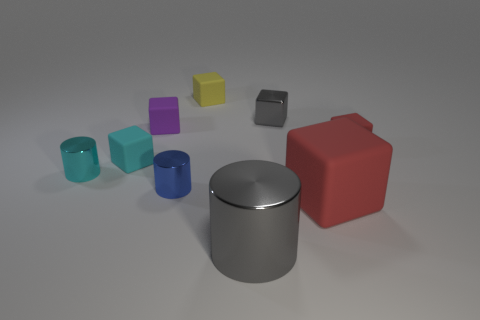Does the cube behind the metallic block have the same size as the small blue metal thing?
Give a very brief answer. Yes. What number of small metallic things are on the left side of the tiny cyan block?
Ensure brevity in your answer.  1. Are there any brown matte blocks of the same size as the blue metal object?
Your answer should be compact. No. Does the small metal cube have the same color as the big metal thing?
Your answer should be compact. Yes. There is a large thing that is to the right of the large metallic object in front of the tiny purple thing; what color is it?
Your answer should be compact. Red. How many objects are behind the small cyan block and to the right of the tiny gray object?
Your response must be concise. 1. How many other big gray metal objects are the same shape as the big metallic thing?
Your response must be concise. 0. Do the small yellow thing and the small cyan block have the same material?
Your answer should be very brief. Yes. There is a gray metallic thing that is in front of the gray object to the right of the gray cylinder; what shape is it?
Your response must be concise. Cylinder. There is a red rubber thing that is in front of the tiny blue metal object; how many tiny red rubber blocks are left of it?
Keep it short and to the point. 0. 